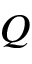Convert formula to latex. <formula><loc_0><loc_0><loc_500><loc_500>Q</formula> 